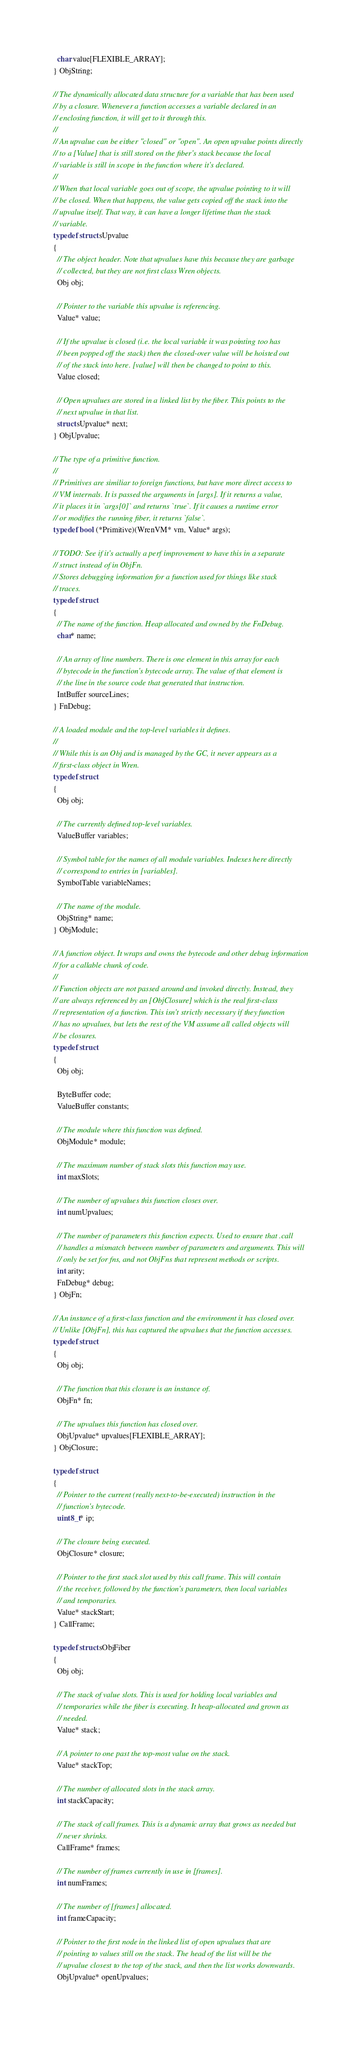Convert code to text. <code><loc_0><loc_0><loc_500><loc_500><_C_>  char value[FLEXIBLE_ARRAY];
} ObjString;

// The dynamically allocated data structure for a variable that has been used
// by a closure. Whenever a function accesses a variable declared in an
// enclosing function, it will get to it through this.
//
// An upvalue can be either "closed" or "open". An open upvalue points directly
// to a [Value] that is still stored on the fiber's stack because the local
// variable is still in scope in the function where it's declared.
//
// When that local variable goes out of scope, the upvalue pointing to it will
// be closed. When that happens, the value gets copied off the stack into the
// upvalue itself. That way, it can have a longer lifetime than the stack
// variable.
typedef struct sUpvalue
{
  // The object header. Note that upvalues have this because they are garbage
  // collected, but they are not first class Wren objects.
  Obj obj;

  // Pointer to the variable this upvalue is referencing.
  Value* value;

  // If the upvalue is closed (i.e. the local variable it was pointing too has
  // been popped off the stack) then the closed-over value will be hoisted out
  // of the stack into here. [value] will then be changed to point to this.
  Value closed;

  // Open upvalues are stored in a linked list by the fiber. This points to the
  // next upvalue in that list.
  struct sUpvalue* next;
} ObjUpvalue;

// The type of a primitive function.
//
// Primitives are similiar to foreign functions, but have more direct access to
// VM internals. It is passed the arguments in [args]. If it returns a value,
// it places it in `args[0]` and returns `true`. If it causes a runtime error
// or modifies the running fiber, it returns `false`.
typedef bool (*Primitive)(WrenVM* vm, Value* args);

// TODO: See if it's actually a perf improvement to have this in a separate
// struct instead of in ObjFn.
// Stores debugging information for a function used for things like stack
// traces.
typedef struct
{
  // The name of the function. Heap allocated and owned by the FnDebug.
  char* name;

  // An array of line numbers. There is one element in this array for each
  // bytecode in the function's bytecode array. The value of that element is
  // the line in the source code that generated that instruction.
  IntBuffer sourceLines;
} FnDebug;

// A loaded module and the top-level variables it defines.
//
// While this is an Obj and is managed by the GC, it never appears as a
// first-class object in Wren.
typedef struct
{
  Obj obj;

  // The currently defined top-level variables.
  ValueBuffer variables;

  // Symbol table for the names of all module variables. Indexes here directly
  // correspond to entries in [variables].
  SymbolTable variableNames;

  // The name of the module.
  ObjString* name;
} ObjModule;

// A function object. It wraps and owns the bytecode and other debug information
// for a callable chunk of code.
//
// Function objects are not passed around and invoked directly. Instead, they
// are always referenced by an [ObjClosure] which is the real first-class
// representation of a function. This isn't strictly necessary if they function
// has no upvalues, but lets the rest of the VM assume all called objects will
// be closures.
typedef struct
{
  Obj obj;
  
  ByteBuffer code;
  ValueBuffer constants;
  
  // The module where this function was defined.
  ObjModule* module;

  // The maximum number of stack slots this function may use.
  int maxSlots;
  
  // The number of upvalues this function closes over.
  int numUpvalues;
  
  // The number of parameters this function expects. Used to ensure that .call
  // handles a mismatch between number of parameters and arguments. This will
  // only be set for fns, and not ObjFns that represent methods or scripts.
  int arity;
  FnDebug* debug;
} ObjFn;

// An instance of a first-class function and the environment it has closed over.
// Unlike [ObjFn], this has captured the upvalues that the function accesses.
typedef struct
{
  Obj obj;

  // The function that this closure is an instance of.
  ObjFn* fn;

  // The upvalues this function has closed over.
  ObjUpvalue* upvalues[FLEXIBLE_ARRAY];
} ObjClosure;

typedef struct
{
  // Pointer to the current (really next-to-be-executed) instruction in the
  // function's bytecode.
  uint8_t* ip;
  
  // The closure being executed.
  ObjClosure* closure;
  
  // Pointer to the first stack slot used by this call frame. This will contain
  // the receiver, followed by the function's parameters, then local variables
  // and temporaries.
  Value* stackStart;
} CallFrame;

typedef struct sObjFiber
{
  Obj obj;
  
  // The stack of value slots. This is used for holding local variables and
  // temporaries while the fiber is executing. It heap-allocated and grown as
  // needed.
  Value* stack;
  
  // A pointer to one past the top-most value on the stack.
  Value* stackTop;
  
  // The number of allocated slots in the stack array.
  int stackCapacity;
  
  // The stack of call frames. This is a dynamic array that grows as needed but
  // never shrinks.
  CallFrame* frames;
  
  // The number of frames currently in use in [frames].
  int numFrames;
  
  // The number of [frames] allocated.
  int frameCapacity;
  
  // Pointer to the first node in the linked list of open upvalues that are
  // pointing to values still on the stack. The head of the list will be the
  // upvalue closest to the top of the stack, and then the list works downwards.
  ObjUpvalue* openUpvalues;
  </code> 